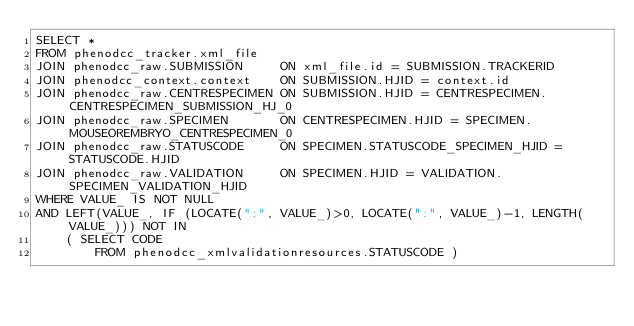<code> <loc_0><loc_0><loc_500><loc_500><_SQL_>SELECT *
FROM phenodcc_tracker.xml_file
JOIN phenodcc_raw.SUBMISSION     ON xml_file.id = SUBMISSION.TRACKERID
JOIN phenodcc_context.context    ON SUBMISSION.HJID = context.id
JOIN phenodcc_raw.CENTRESPECIMEN ON SUBMISSION.HJID = CENTRESPECIMEN.CENTRESPECIMEN_SUBMISSION_HJ_0
JOIN phenodcc_raw.SPECIMEN       ON CENTRESPECIMEN.HJID = SPECIMEN.MOUSEOREMBRYO_CENTRESPECIMEN_0
JOIN phenodcc_raw.STATUSCODE     ON SPECIMEN.STATUSCODE_SPECIMEN_HJID = STATUSCODE.HJID
JOIN phenodcc_raw.VALIDATION     ON SPECIMEN.HJID = VALIDATION.SPECIMEN_VALIDATION_HJID
WHERE VALUE_ IS NOT NULL
AND LEFT(VALUE_, IF (LOCATE(":", VALUE_)>0, LOCATE(":", VALUE_)-1, LENGTH(VALUE_))) NOT IN
    ( SELECT CODE
        FROM phenodcc_xmlvalidationresources.STATUSCODE )</code> 